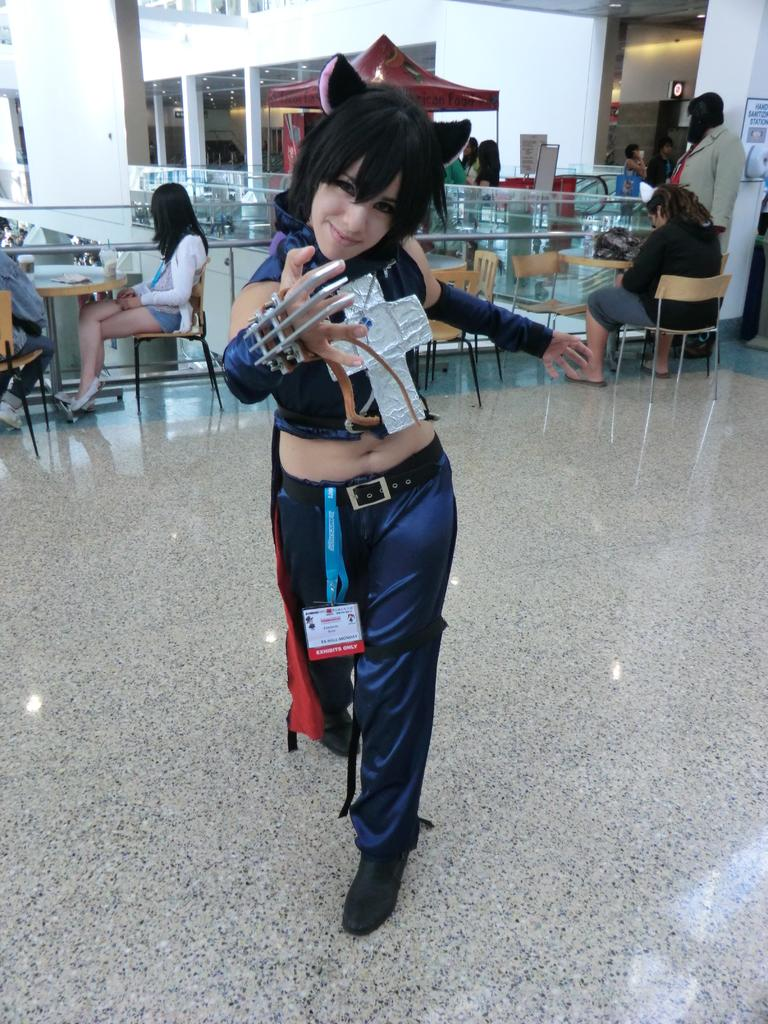What is the main subject of the image? The main subject of the image is a woman standing. What is the woman wearing in the image? The woman is wearing an identity card in the image. What is happening in the background of the image? There are people sitting in front of a table in the background of the image. What type of advertisement can be seen on the table in the image? There is no advertisement present on the table in the image. What day of the week is it in the image? The day of the week cannot be determined from the image. What time of day is it in the image? The time of day cannot be determined from the image. 